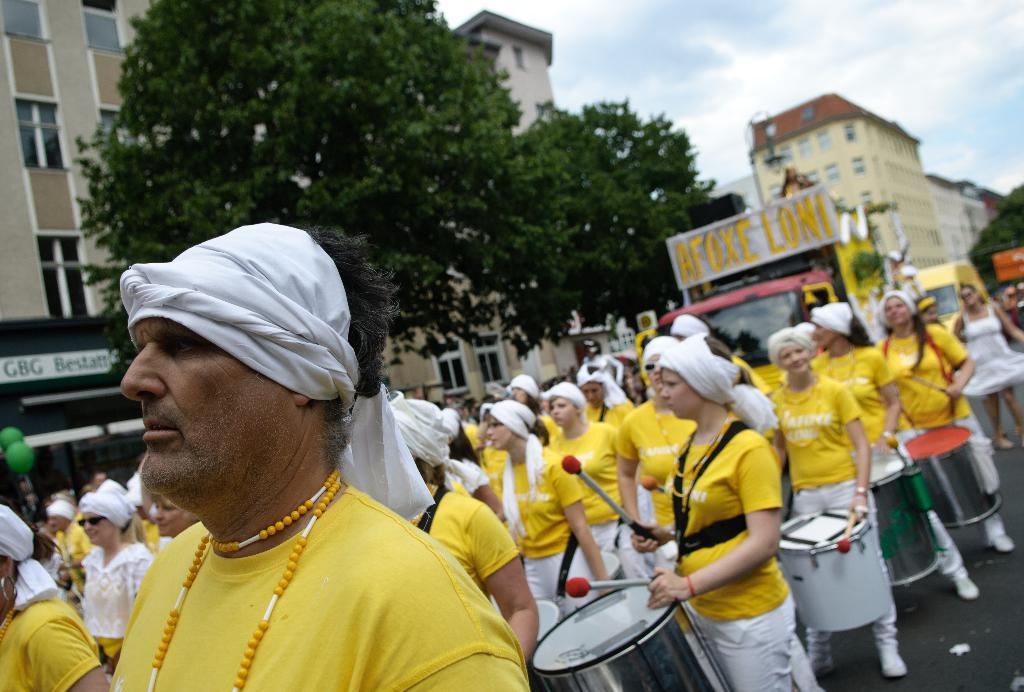How many people are in the image? There is a group of people in the image, but the exact number cannot be determined from the provided facts. What else can be seen on the road in the image? There are vehicles on the road in the image. What structures are visible in the image? There are buildings visible in the image. What type of vegetation is present in the image? There are trees in the image. What is visible in the background of the image? The sky is visible in the background of the image. What type of toe is visible on the person in the image? There is no specific toe visible in the image, as it does not focus on any individual person's body parts. What is the weather like in the image? The provided facts do not mention any details about the weather, so it cannot be determined from the image. 